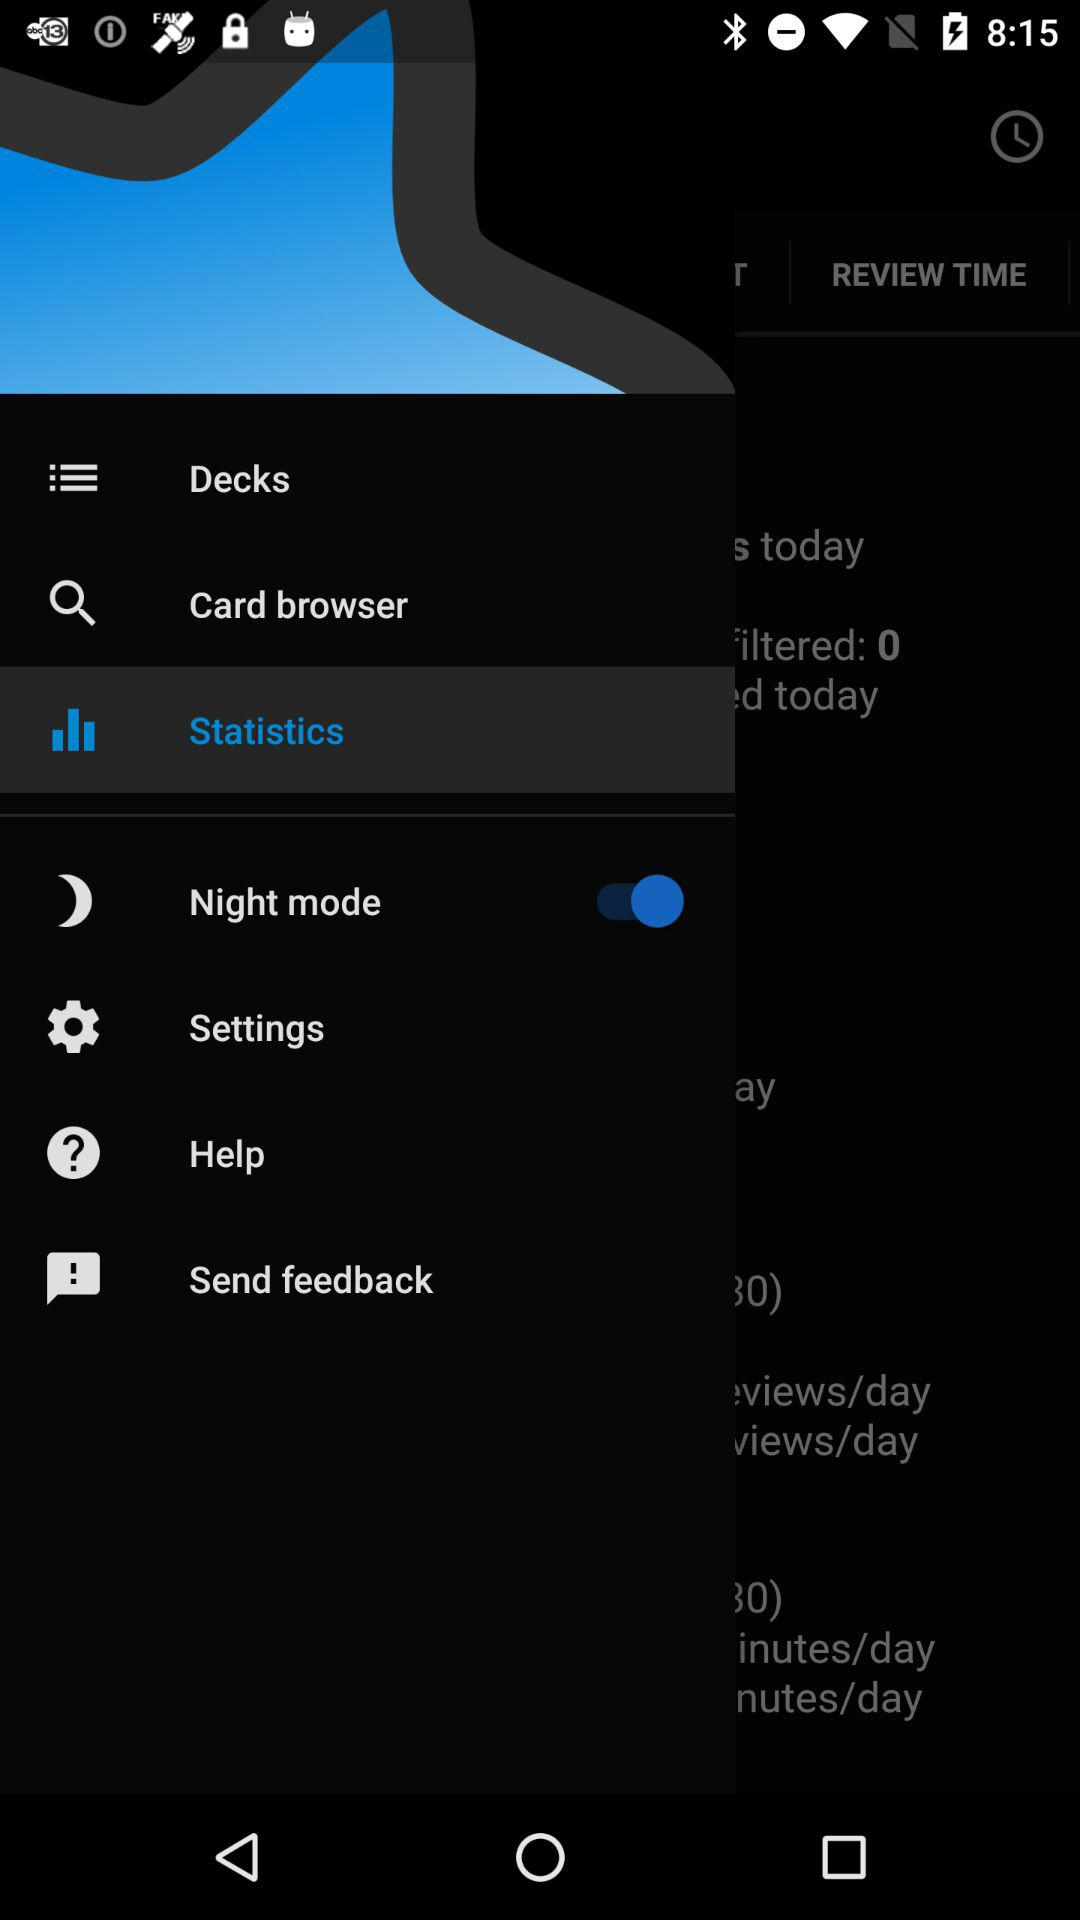Which item has been selected? The selected item is "Statistics". 